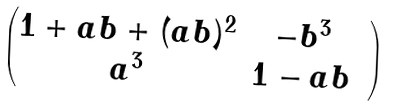<formula> <loc_0><loc_0><loc_500><loc_500>\begin{pmatrix} 1 + a b + ( a b ) ^ { 2 } & - b ^ { 3 } & \\ a ^ { 3 } & 1 - a b \\ \end{pmatrix}</formula> 